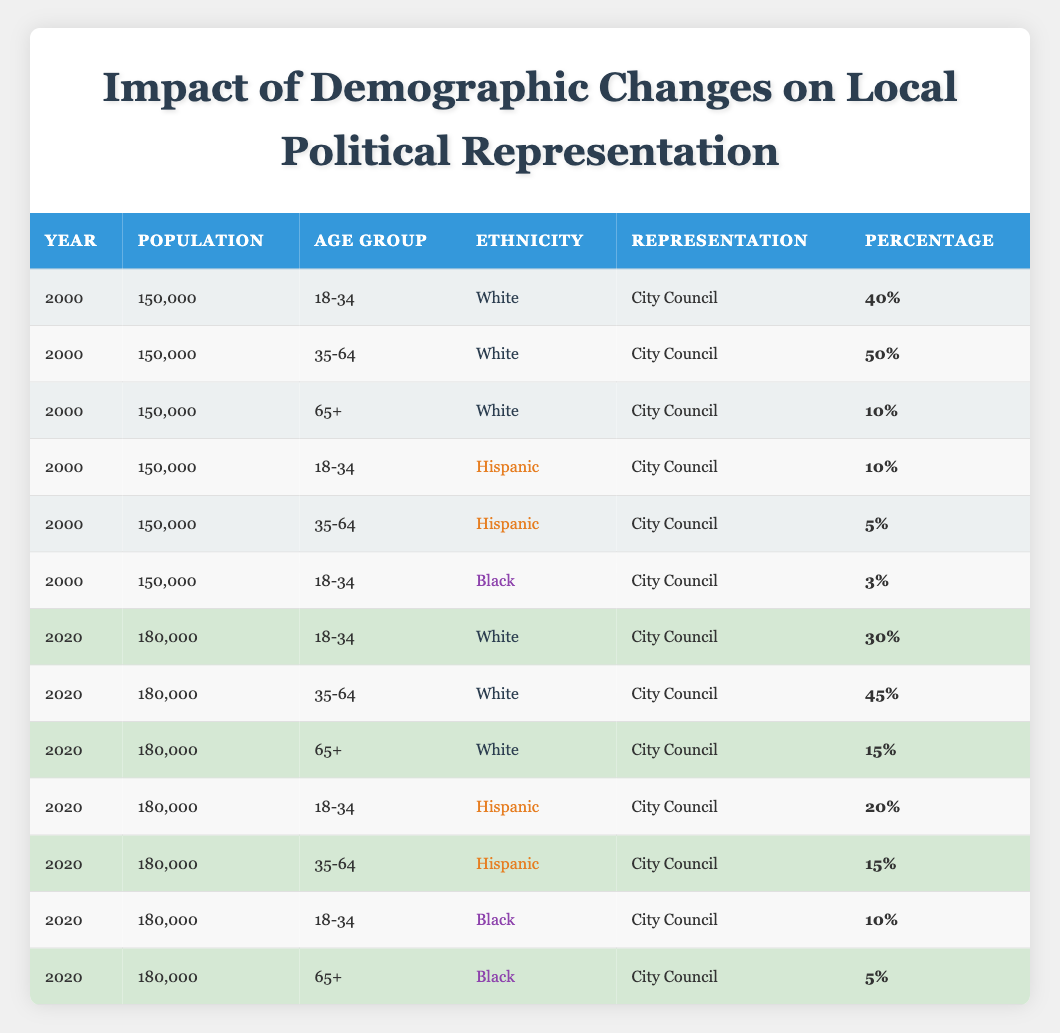What was the percentage of representation for Hispanic individuals aged 18-34 in 2000? In 2000, the table shows that Hispanic individuals in the age group 18-34 had a representation percentage of 10%.
Answer: 10% What is the total percentage of representation for White individuals in the age group 35-64 across both years? In 2000, White individuals aged 35-64 had a representation percentage of 50%, and in 2020, this group had a percentage of 45%. Adding these gives 50% + 45% = 95%.
Answer: 95% Did the representation percentage for Black individuals aged 65+ increase from 2000 to 2020? In 2000, Black individuals aged 65+ had a representation percentage of 0%, while in 2020 they had 5%. Since 5% is greater than 0%, the percentage did increase.
Answer: Yes What is the average representation percentage for Hispanic individuals in both years across all age groups? In 2000, Hispanic individuals had representation percentages of 10% (age 18-34) and 5% (age 35-64) leading to a sum of 15%. In 2020, they had 20% (age 18-34) and 15% (age 35-64) summing to 35%. Combining both years gives 15% + 35% = 50%. The average across 4 data points is 50% / 4 = 12.5%.
Answer: 12.5% What percentage of the total population represented the age group 65+ for White individuals in 2020? In 2020, White individuals aged 65+ represented 15%, which is derived from their row in the table.
Answer: 15% How did the representation percentage for White individuals aged 18-34 change from 2000 to 2020? In 2000, the percentage was 40%, and in 2020 it decreased to 30%. The change is computed as 30% - 40% = -10%. This reflects a decrease of 10 percentage points.
Answer: Decreased by 10 percentage points What proportion of the total representation in 2020 was accounted for by Black individuals in the age group 18-34? In 2020, Black individuals aged 18-34 had a representation of 10%. The total population for the year was 180,000. Representationally, this percentage accounts for (10% of 180,000) which is 0.05556 in proportion terms.
Answer: 10% What was the combined representation for individuals aged 65+ across all ethnicities in both years? The representation for individuals aged 65+ in 2000 was 10% (White) and for 2020 it was 15% (White) + 5% (Black) = 20%. Combined gives 10% + 20% = 30%.
Answer: 30% 